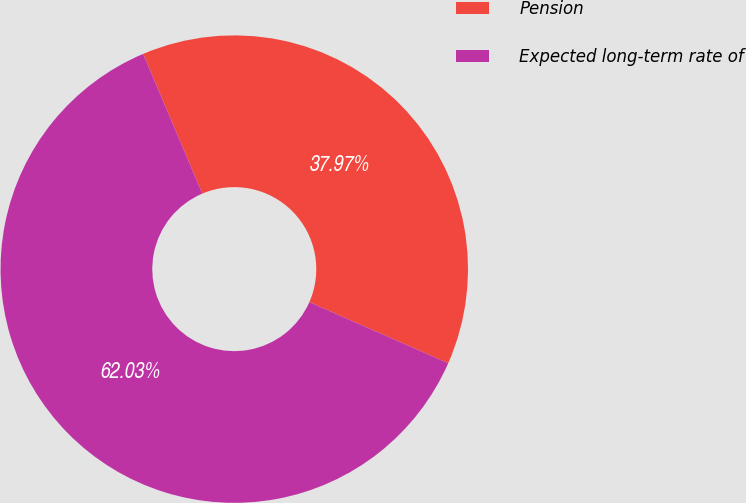Convert chart. <chart><loc_0><loc_0><loc_500><loc_500><pie_chart><fcel>Pension<fcel>Expected long-term rate of<nl><fcel>37.97%<fcel>62.03%<nl></chart> 